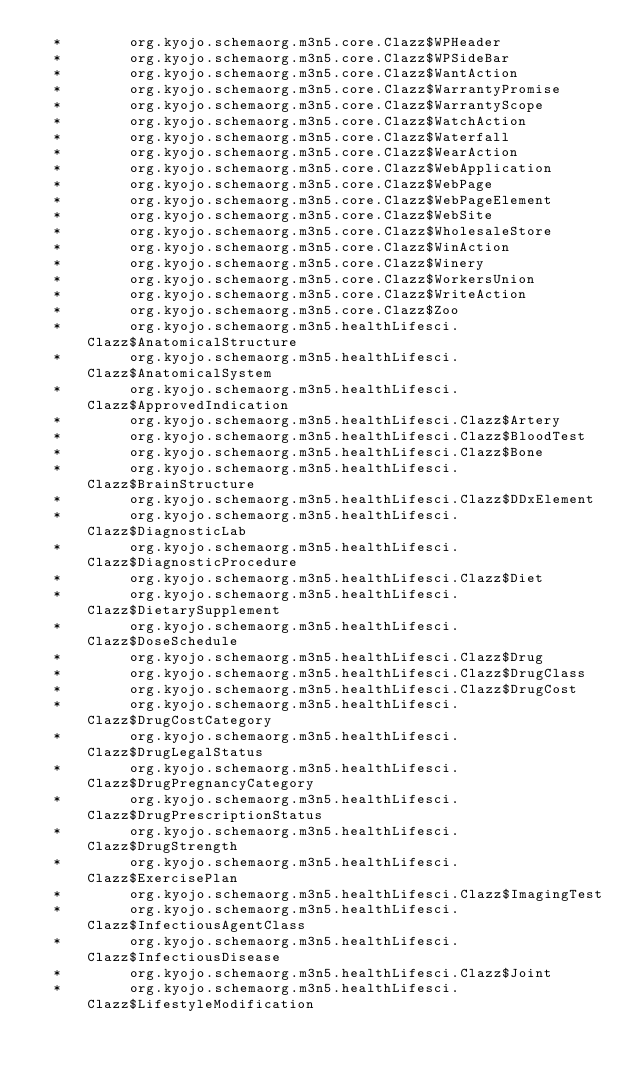Convert code to text. <code><loc_0><loc_0><loc_500><loc_500><_SQL_>  *        org.kyojo.schemaorg.m3n5.core.Clazz$WPHeader
  *        org.kyojo.schemaorg.m3n5.core.Clazz$WPSideBar
  *        org.kyojo.schemaorg.m3n5.core.Clazz$WantAction
  *        org.kyojo.schemaorg.m3n5.core.Clazz$WarrantyPromise
  *        org.kyojo.schemaorg.m3n5.core.Clazz$WarrantyScope
  *        org.kyojo.schemaorg.m3n5.core.Clazz$WatchAction
  *        org.kyojo.schemaorg.m3n5.core.Clazz$Waterfall
  *        org.kyojo.schemaorg.m3n5.core.Clazz$WearAction
  *        org.kyojo.schemaorg.m3n5.core.Clazz$WebApplication
  *        org.kyojo.schemaorg.m3n5.core.Clazz$WebPage
  *        org.kyojo.schemaorg.m3n5.core.Clazz$WebPageElement
  *        org.kyojo.schemaorg.m3n5.core.Clazz$WebSite
  *        org.kyojo.schemaorg.m3n5.core.Clazz$WholesaleStore
  *        org.kyojo.schemaorg.m3n5.core.Clazz$WinAction
  *        org.kyojo.schemaorg.m3n5.core.Clazz$Winery
  *        org.kyojo.schemaorg.m3n5.core.Clazz$WorkersUnion
  *        org.kyojo.schemaorg.m3n5.core.Clazz$WriteAction
  *        org.kyojo.schemaorg.m3n5.core.Clazz$Zoo
  *        org.kyojo.schemaorg.m3n5.healthLifesci.Clazz$AnatomicalStructure
  *        org.kyojo.schemaorg.m3n5.healthLifesci.Clazz$AnatomicalSystem
  *        org.kyojo.schemaorg.m3n5.healthLifesci.Clazz$ApprovedIndication
  *        org.kyojo.schemaorg.m3n5.healthLifesci.Clazz$Artery
  *        org.kyojo.schemaorg.m3n5.healthLifesci.Clazz$BloodTest
  *        org.kyojo.schemaorg.m3n5.healthLifesci.Clazz$Bone
  *        org.kyojo.schemaorg.m3n5.healthLifesci.Clazz$BrainStructure
  *        org.kyojo.schemaorg.m3n5.healthLifesci.Clazz$DDxElement
  *        org.kyojo.schemaorg.m3n5.healthLifesci.Clazz$DiagnosticLab
  *        org.kyojo.schemaorg.m3n5.healthLifesci.Clazz$DiagnosticProcedure
  *        org.kyojo.schemaorg.m3n5.healthLifesci.Clazz$Diet
  *        org.kyojo.schemaorg.m3n5.healthLifesci.Clazz$DietarySupplement
  *        org.kyojo.schemaorg.m3n5.healthLifesci.Clazz$DoseSchedule
  *        org.kyojo.schemaorg.m3n5.healthLifesci.Clazz$Drug
  *        org.kyojo.schemaorg.m3n5.healthLifesci.Clazz$DrugClass
  *        org.kyojo.schemaorg.m3n5.healthLifesci.Clazz$DrugCost
  *        org.kyojo.schemaorg.m3n5.healthLifesci.Clazz$DrugCostCategory
  *        org.kyojo.schemaorg.m3n5.healthLifesci.Clazz$DrugLegalStatus
  *        org.kyojo.schemaorg.m3n5.healthLifesci.Clazz$DrugPregnancyCategory
  *        org.kyojo.schemaorg.m3n5.healthLifesci.Clazz$DrugPrescriptionStatus
  *        org.kyojo.schemaorg.m3n5.healthLifesci.Clazz$DrugStrength
  *        org.kyojo.schemaorg.m3n5.healthLifesci.Clazz$ExercisePlan
  *        org.kyojo.schemaorg.m3n5.healthLifesci.Clazz$ImagingTest
  *        org.kyojo.schemaorg.m3n5.healthLifesci.Clazz$InfectiousAgentClass
  *        org.kyojo.schemaorg.m3n5.healthLifesci.Clazz$InfectiousDisease
  *        org.kyojo.schemaorg.m3n5.healthLifesci.Clazz$Joint
  *        org.kyojo.schemaorg.m3n5.healthLifesci.Clazz$LifestyleModification</code> 